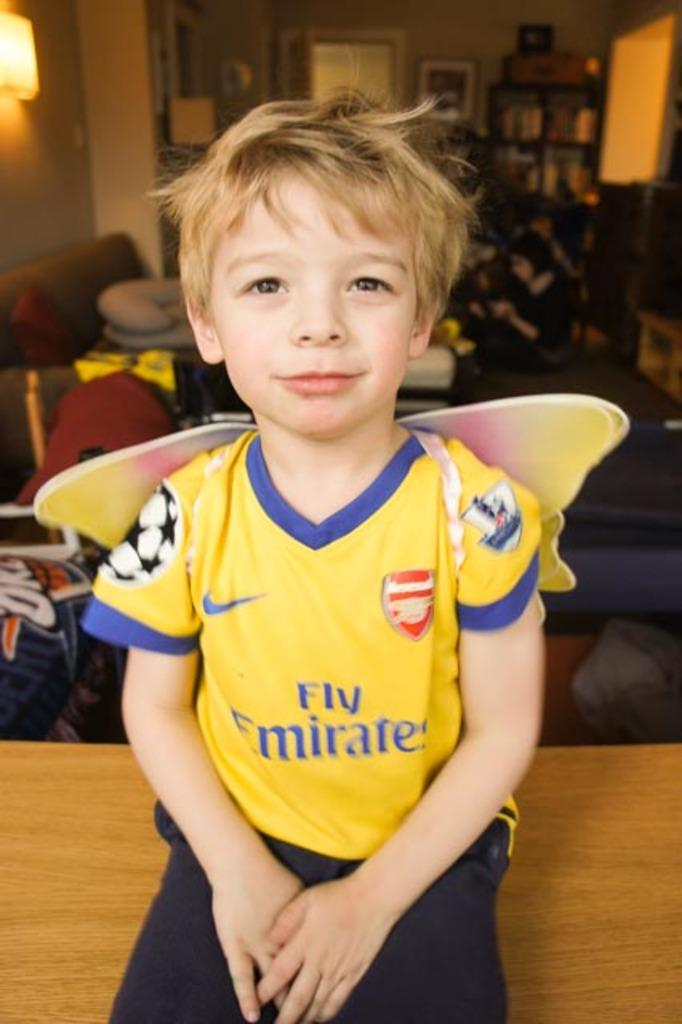<image>
Give a short and clear explanation of the subsequent image. a boy with a winged shirt on that says Fly Emirates on the front, and has sports logos. 